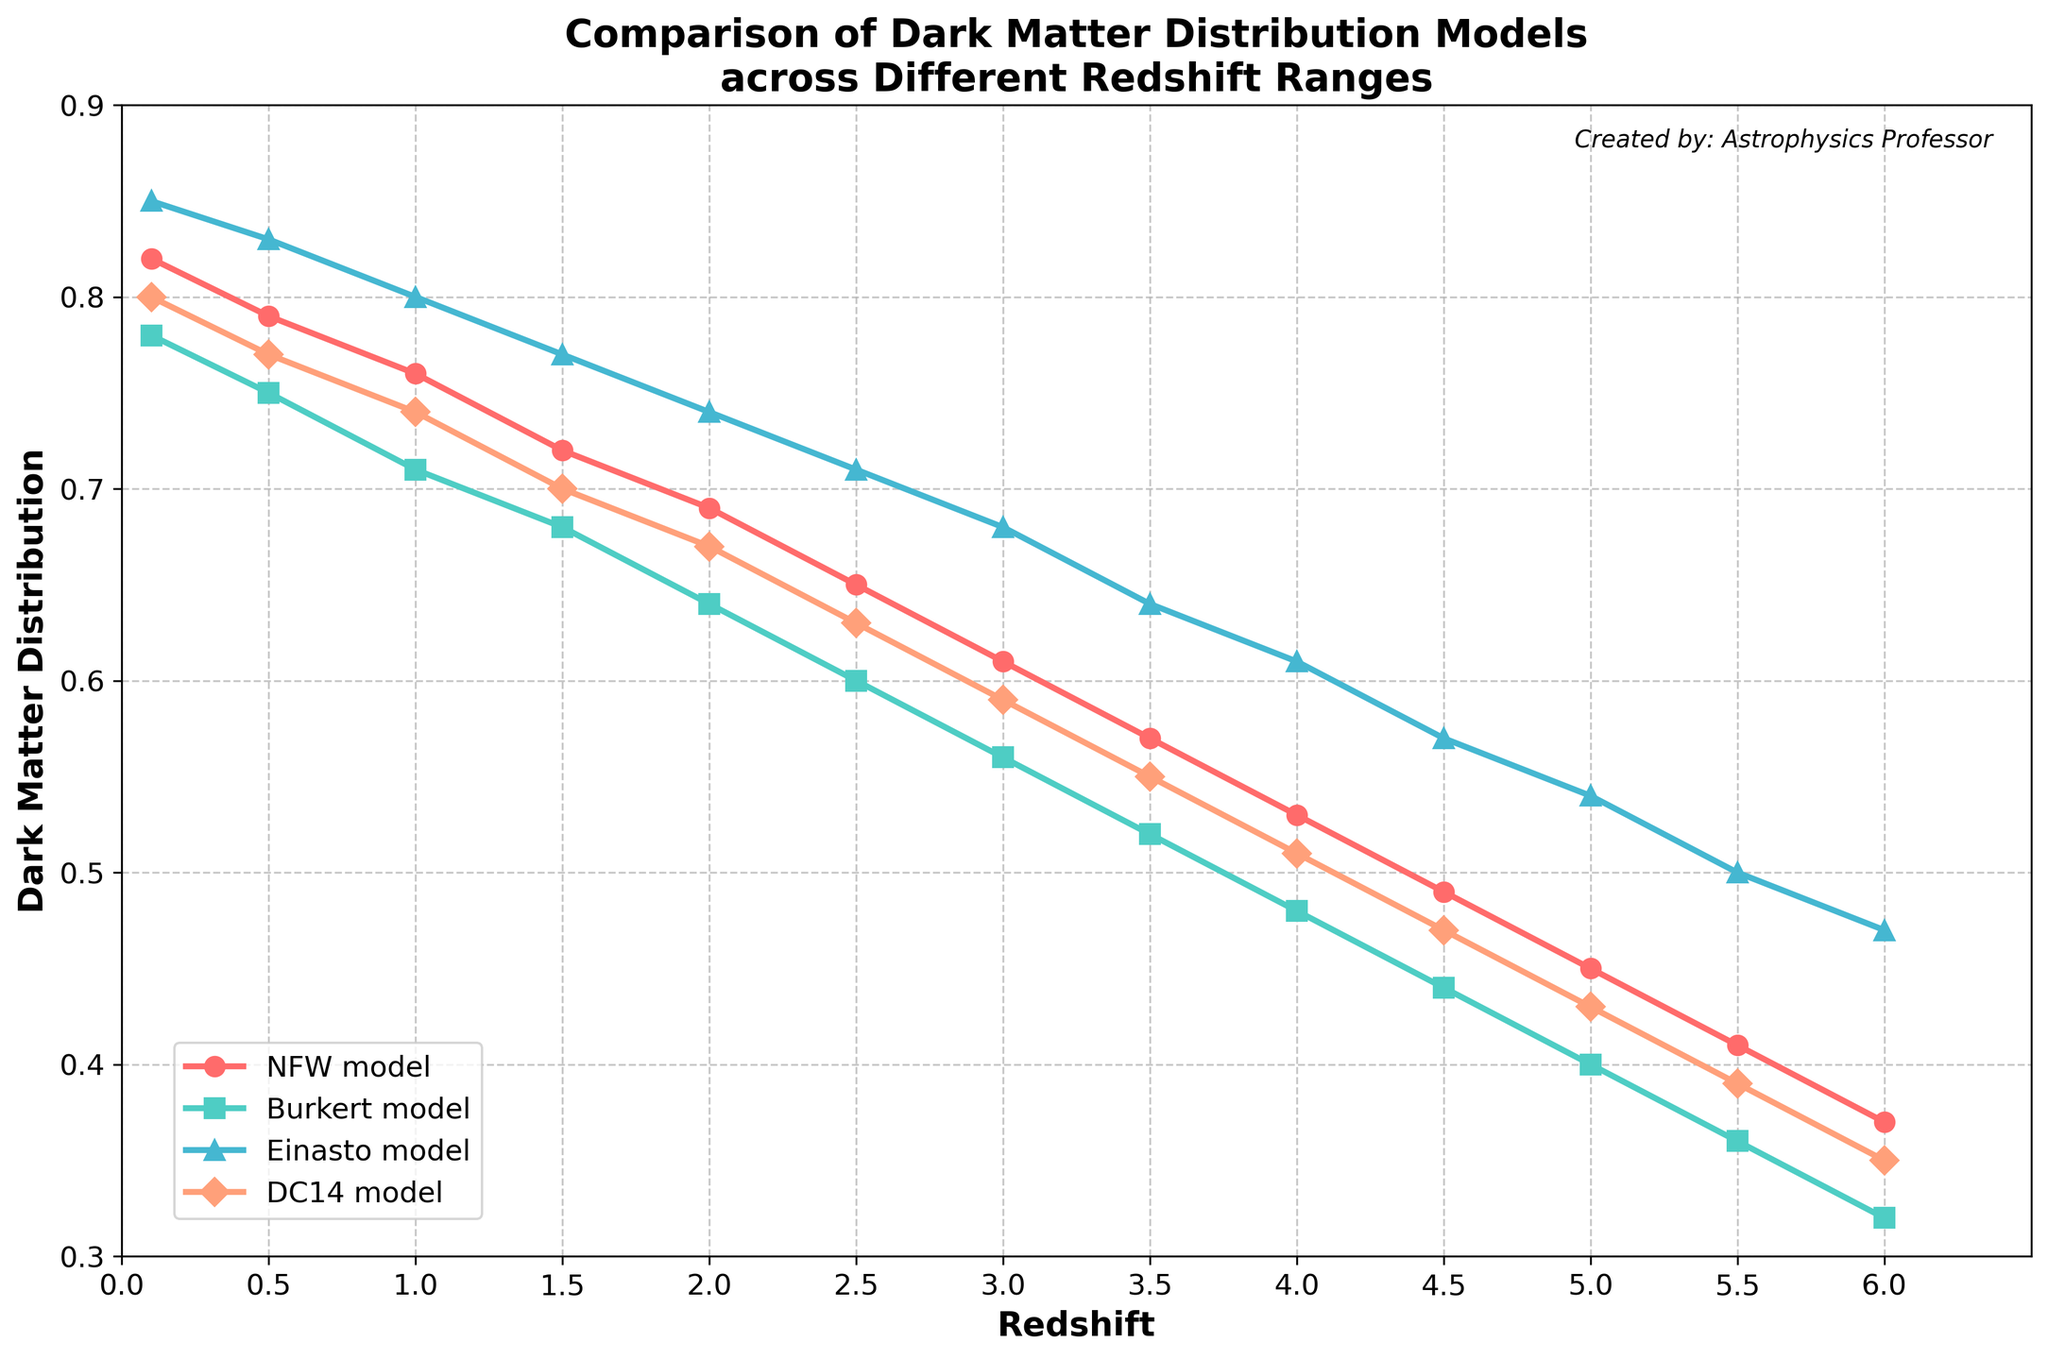What trend do you observe for the NFW model as the redshift increases? As redshift increases from 0.1 to 6.0, the value for the NFW model decreases steadily from 0.82 to 0.37, showing a consistent downward trend.
Answer: Decreasing trend Which model has the highest value at redshift 2.0? At redshift 2.0, the values for the models are: 0.69 (NFW), 0.64 (Burkert), 0.74 (Einasto), and 0.67 (DC14). The highest value is for the Einasto model.
Answer: Einasto At redshift 4.0, which model has the smallest value? At redshift 4.0, the values are: 0.53 (NFW), 0.48 (Burkert), 0.61 (Einasto), and 0.51 (DC14). The smallest value is for the Burkert model.
Answer: Burkert How does the DC14 model's value change between redshift 1.0 and 5.0? The value for the DC14 model at redshift 1.0 is 0.74 and at 5.0 is 0.43. The change is 0.74 - 0.43 = 0.31, indicating a decrease of 0.31.
Answer: Decrease of 0.31 Which model shows the most significant change from redshift 0.1 to 6.0? Over the redshift range from 0.1 to 6.0, the changes are: 0.82 - 0.37 = 0.45 (NFW), 0.78 - 0.32 = 0.46 (Burkert), 0.85 - 0.47 = 0.38 (Einasto), and 0.80 - 0.35 = 0.45 (DC14). The most significant change is for the Burkert model.
Answer: Burkert What is the approximate average value of the Einasto model over all redshifts? The values for the Einasto model are: 0.85, 0.83, 0.80, 0.77, 0.74, 0.71, 0.68, 0.64, 0.61, 0.57, 0.54, 0.50, 0.47. Summing these gives 8.91. There are 13 values, so the average is 8.91 / 13 ≈ 0.69.
Answer: ≈ 0.69 Which model has the flattest decrease in values from 0.1 to 6.0? To determine the flattest decrease, we look at the differences over the range: 0.45 (NFW), 0.46 (Burkert), 0.38 (Einasto), 0.45 (DC14). The smallest difference is for the Einasto model, indicating the flattest decrease.
Answer: Einasto Between redshift 2.0 and 4.0, which model decreases the most? From redshift 2.0 to 4.0, the changes in values are: 0.69 - 0.53 = 0.16 (NFW), 0.64 - 0.48 = 0.16 (Burkert), 0.74 - 0.61 = 0.13 (Einasto), and 0.67 - 0.51 = 0.16 (DC14). All models, except Einasto, share the same decrease, which is the most significant.
Answer: NFW, Burkert, DC14 How do the values of Burkert and DC14 models compare at redshift 3.5? At redshift 3.5, the values are: 0.52 (Burkert) and 0.55 (DC14). Comparing these, Burkert has a smaller value than DC14.
Answer: Burkert < DC14 